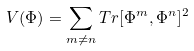<formula> <loc_0><loc_0><loc_500><loc_500>V ( \Phi ) = \sum _ { m \neq n } T r [ \Phi ^ { m } , \Phi ^ { n } ] ^ { 2 }</formula> 